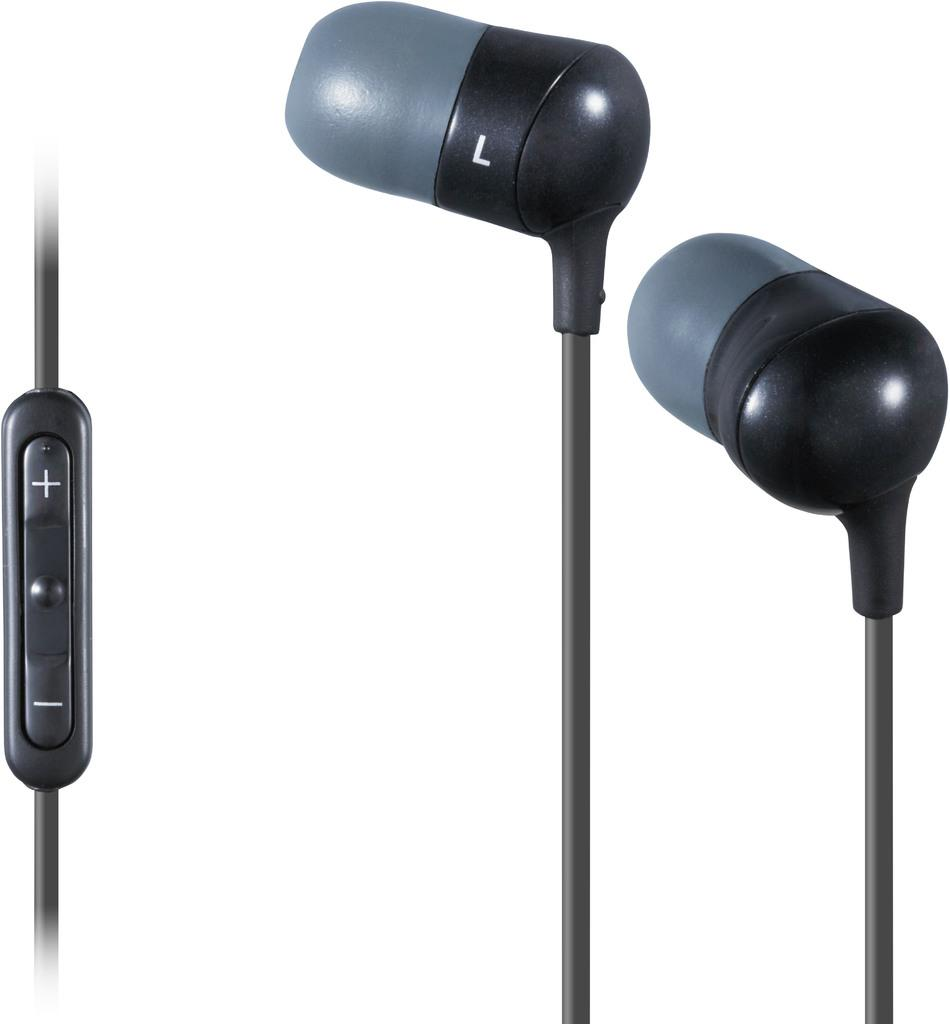What is located on the left side of the image? There is a volume controller of an earphone on the left side of the image. What is on the right side of the image? There are ear buds on the right side of the image. What color is the background of the image? The background of the image is white. What type of test can be seen being conducted on the wren in the image? There is no wren or test present in the image; it features a volume controller and ear buds. 